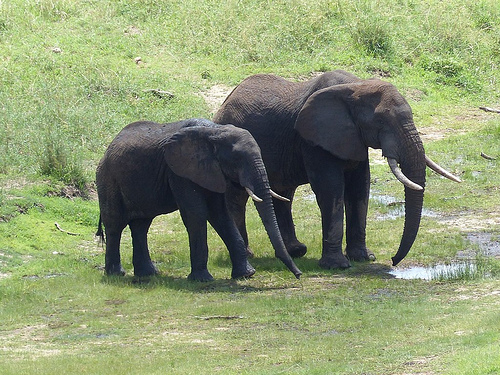Do elephants usually have this kind of environment? Yes, elephants typically thrive in environments like this grassy and muddy area. Such habitats provide them with the food and water they need, as well as space to move around and interact with other members of their group. Are these elephants likely to be a family? Yes, it's very likely that these elephants are part of a family group or herd. Elephants are social animals and often travel in groups that are usually led by a matriarch. How would the elephants spend their day in this setting? In this setting, elephants might spend their day grazing on the grass, drinking from water sources, mud bathing to protect their skin from the sun and insects, and socializing with each other. They might also engage in playful interactions, especially the younger elephants, who often play games and learn essential skills from the adults. Imagine if these elephants suddenly started singing a song. What would it be about? If the elephants started singing a song, it might be about their adventurous journeys across the savanna, the joy of finding fresh water, the warmth of family bonds, and the majestic beauty of nature that surrounds them. The song would likely echo the sounds of the wilderness, resonating with themes of freedom, togetherness, and harmony within their vibrant ecosystem. 